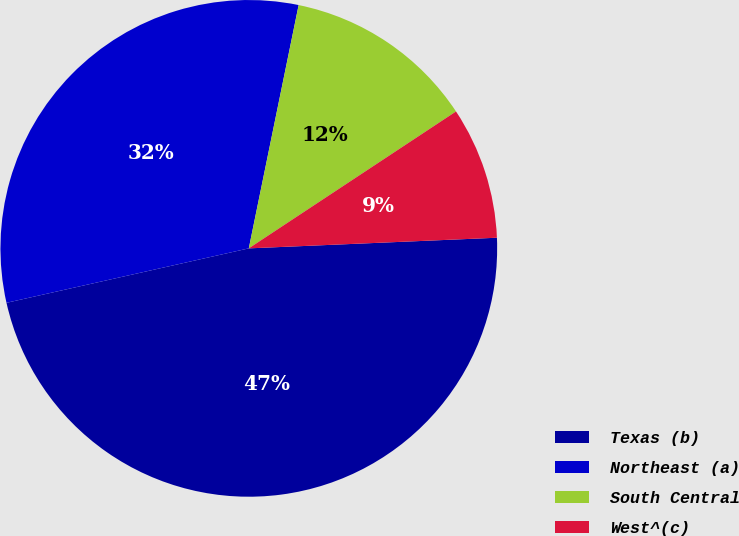Convert chart to OTSL. <chart><loc_0><loc_0><loc_500><loc_500><pie_chart><fcel>Texas (b)<fcel>Northeast (a)<fcel>South Central<fcel>West^(c)<nl><fcel>47.16%<fcel>31.73%<fcel>12.49%<fcel>8.61%<nl></chart> 